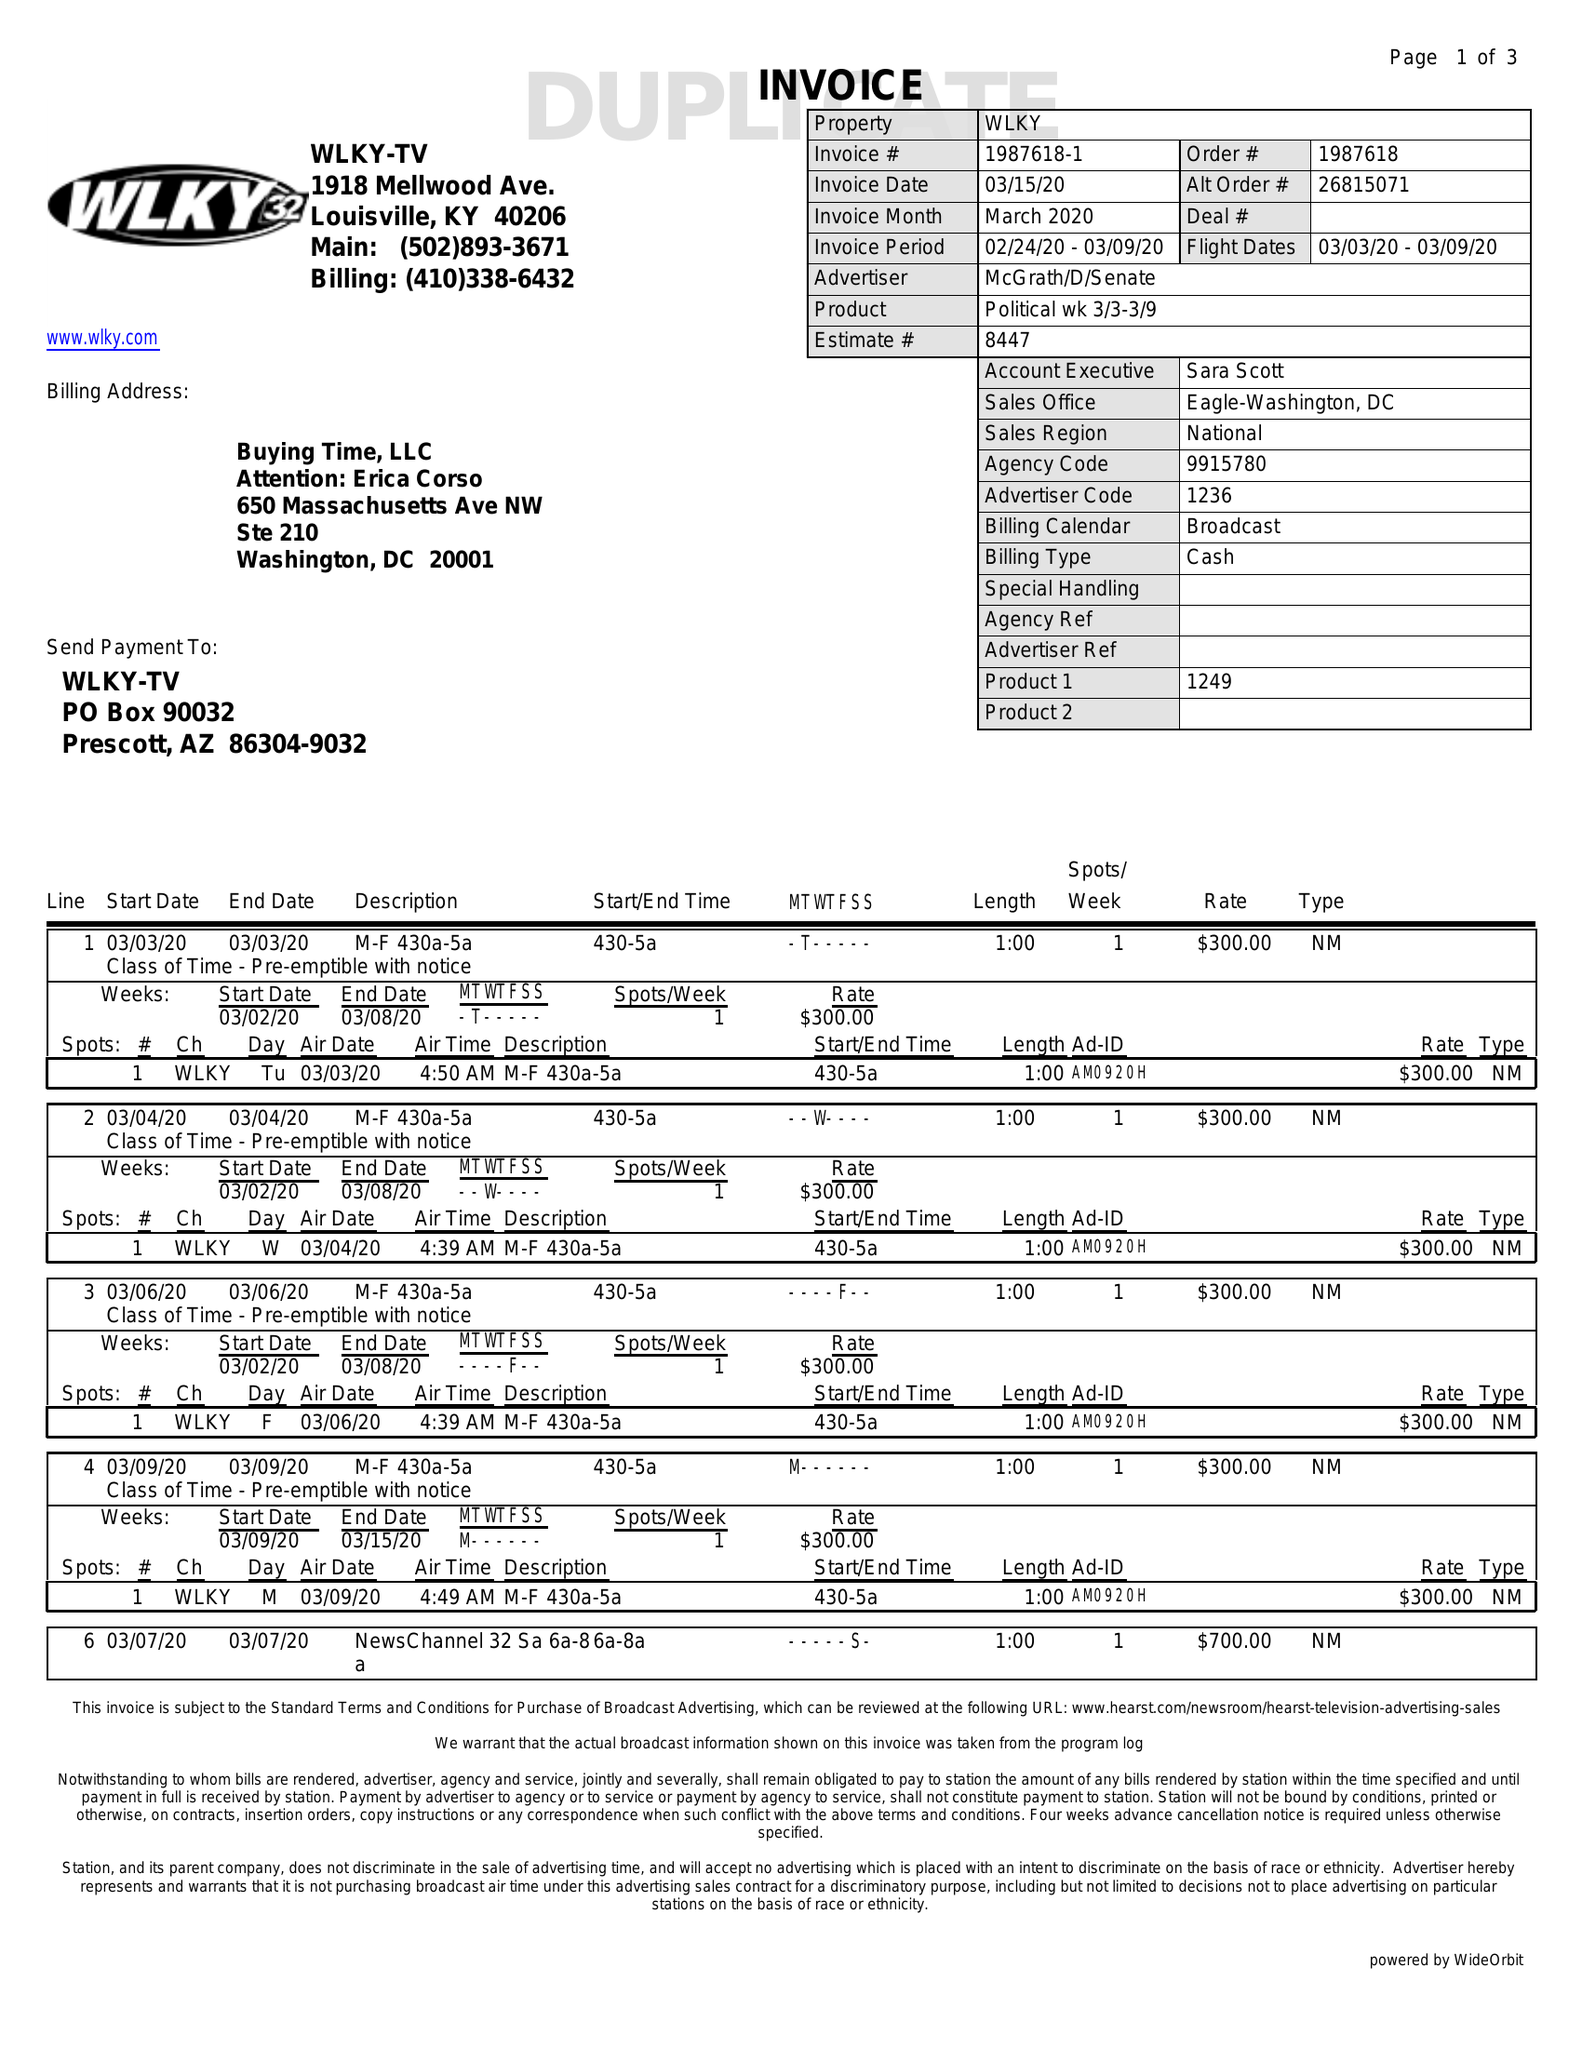What is the value for the advertiser?
Answer the question using a single word or phrase. MCGRATH/D/SENATE 